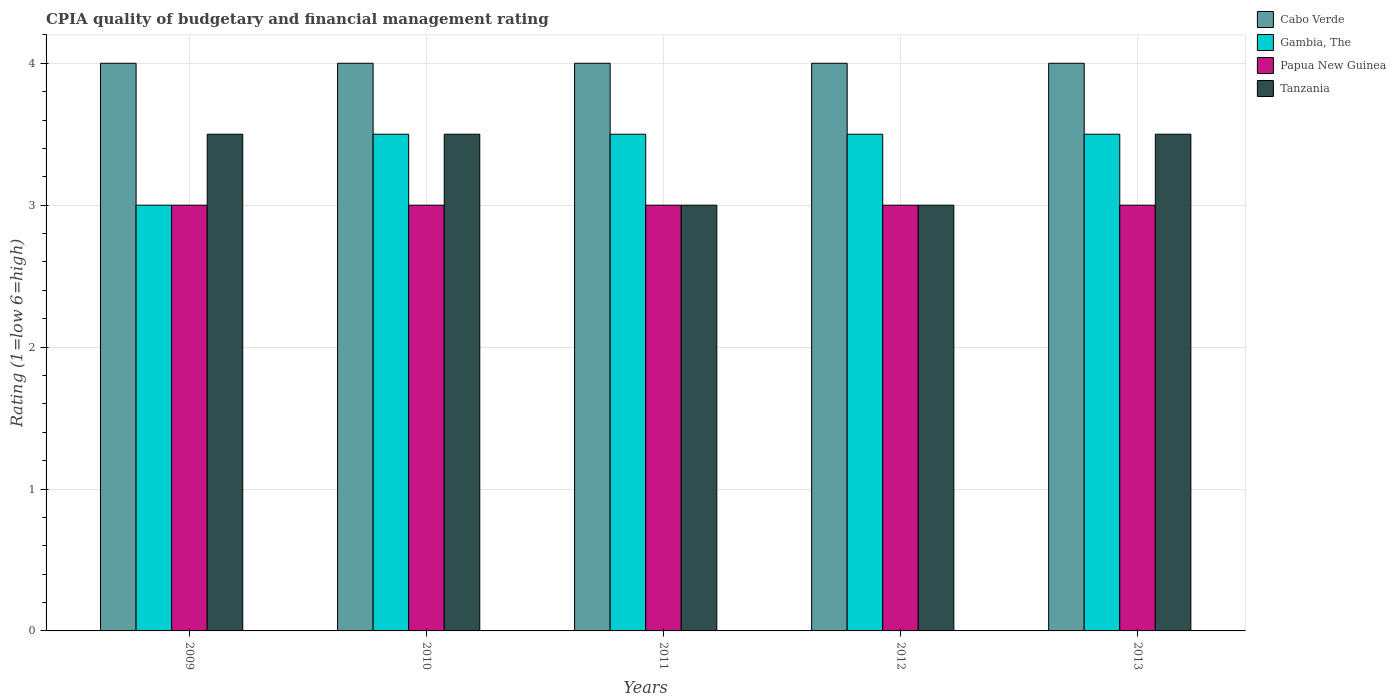How many different coloured bars are there?
Your answer should be compact. 4. Are the number of bars per tick equal to the number of legend labels?
Provide a short and direct response. Yes. Are the number of bars on each tick of the X-axis equal?
Your answer should be very brief. Yes. How many bars are there on the 5th tick from the right?
Your answer should be compact. 4. What is the label of the 2nd group of bars from the left?
Provide a succinct answer. 2010. In how many cases, is the number of bars for a given year not equal to the number of legend labels?
Your answer should be compact. 0. What is the CPIA rating in Tanzania in 2013?
Offer a very short reply. 3.5. Across all years, what is the maximum CPIA rating in Gambia, The?
Your answer should be very brief. 3.5. Across all years, what is the minimum CPIA rating in Gambia, The?
Make the answer very short. 3. What is the ratio of the CPIA rating in Papua New Guinea in 2009 to that in 2011?
Your answer should be compact. 1. Is the difference between the CPIA rating in Tanzania in 2012 and 2013 greater than the difference between the CPIA rating in Gambia, The in 2012 and 2013?
Ensure brevity in your answer.  No. What is the difference between the highest and the lowest CPIA rating in Gambia, The?
Ensure brevity in your answer.  0.5. In how many years, is the CPIA rating in Papua New Guinea greater than the average CPIA rating in Papua New Guinea taken over all years?
Provide a succinct answer. 0. Is the sum of the CPIA rating in Cabo Verde in 2009 and 2011 greater than the maximum CPIA rating in Gambia, The across all years?
Ensure brevity in your answer.  Yes. Is it the case that in every year, the sum of the CPIA rating in Tanzania and CPIA rating in Cabo Verde is greater than the sum of CPIA rating in Papua New Guinea and CPIA rating in Gambia, The?
Provide a short and direct response. No. What does the 3rd bar from the left in 2013 represents?
Ensure brevity in your answer.  Papua New Guinea. What does the 3rd bar from the right in 2012 represents?
Offer a very short reply. Gambia, The. Is it the case that in every year, the sum of the CPIA rating in Cabo Verde and CPIA rating in Papua New Guinea is greater than the CPIA rating in Tanzania?
Your response must be concise. Yes. Are all the bars in the graph horizontal?
Keep it short and to the point. No. How many years are there in the graph?
Provide a succinct answer. 5. What is the difference between two consecutive major ticks on the Y-axis?
Your answer should be very brief. 1. Are the values on the major ticks of Y-axis written in scientific E-notation?
Give a very brief answer. No. Does the graph contain any zero values?
Your response must be concise. No. Does the graph contain grids?
Your answer should be compact. Yes. How many legend labels are there?
Offer a terse response. 4. What is the title of the graph?
Provide a succinct answer. CPIA quality of budgetary and financial management rating. Does "Nicaragua" appear as one of the legend labels in the graph?
Offer a terse response. No. What is the Rating (1=low 6=high) of Papua New Guinea in 2009?
Your answer should be very brief. 3. What is the Rating (1=low 6=high) in Tanzania in 2009?
Keep it short and to the point. 3.5. What is the Rating (1=low 6=high) of Gambia, The in 2010?
Provide a short and direct response. 3.5. What is the Rating (1=low 6=high) of Papua New Guinea in 2010?
Provide a short and direct response. 3. What is the Rating (1=low 6=high) in Tanzania in 2010?
Your response must be concise. 3.5. What is the Rating (1=low 6=high) of Cabo Verde in 2011?
Offer a terse response. 4. What is the Rating (1=low 6=high) of Gambia, The in 2011?
Give a very brief answer. 3.5. What is the Rating (1=low 6=high) in Cabo Verde in 2012?
Your answer should be very brief. 4. What is the Rating (1=low 6=high) of Gambia, The in 2012?
Provide a succinct answer. 3.5. What is the Rating (1=low 6=high) in Papua New Guinea in 2012?
Offer a terse response. 3. What is the Rating (1=low 6=high) in Tanzania in 2012?
Make the answer very short. 3. What is the Rating (1=low 6=high) in Cabo Verde in 2013?
Your answer should be compact. 4. What is the Rating (1=low 6=high) in Gambia, The in 2013?
Give a very brief answer. 3.5. What is the Rating (1=low 6=high) of Papua New Guinea in 2013?
Provide a short and direct response. 3. Across all years, what is the maximum Rating (1=low 6=high) of Gambia, The?
Your answer should be compact. 3.5. Across all years, what is the minimum Rating (1=low 6=high) of Cabo Verde?
Offer a terse response. 4. Across all years, what is the minimum Rating (1=low 6=high) in Gambia, The?
Provide a short and direct response. 3. What is the total Rating (1=low 6=high) of Gambia, The in the graph?
Ensure brevity in your answer.  17. What is the total Rating (1=low 6=high) in Papua New Guinea in the graph?
Make the answer very short. 15. What is the difference between the Rating (1=low 6=high) in Cabo Verde in 2009 and that in 2010?
Offer a very short reply. 0. What is the difference between the Rating (1=low 6=high) of Gambia, The in 2009 and that in 2010?
Your answer should be very brief. -0.5. What is the difference between the Rating (1=low 6=high) in Papua New Guinea in 2009 and that in 2010?
Offer a terse response. 0. What is the difference between the Rating (1=low 6=high) of Tanzania in 2009 and that in 2010?
Give a very brief answer. 0. What is the difference between the Rating (1=low 6=high) in Cabo Verde in 2009 and that in 2011?
Your answer should be very brief. 0. What is the difference between the Rating (1=low 6=high) in Tanzania in 2009 and that in 2011?
Give a very brief answer. 0.5. What is the difference between the Rating (1=low 6=high) in Gambia, The in 2009 and that in 2012?
Your response must be concise. -0.5. What is the difference between the Rating (1=low 6=high) in Papua New Guinea in 2009 and that in 2012?
Your response must be concise. 0. What is the difference between the Rating (1=low 6=high) of Papua New Guinea in 2009 and that in 2013?
Offer a very short reply. 0. What is the difference between the Rating (1=low 6=high) of Tanzania in 2009 and that in 2013?
Ensure brevity in your answer.  0. What is the difference between the Rating (1=low 6=high) of Cabo Verde in 2010 and that in 2011?
Provide a succinct answer. 0. What is the difference between the Rating (1=low 6=high) of Cabo Verde in 2010 and that in 2012?
Offer a terse response. 0. What is the difference between the Rating (1=low 6=high) in Gambia, The in 2010 and that in 2012?
Your response must be concise. 0. What is the difference between the Rating (1=low 6=high) of Papua New Guinea in 2010 and that in 2012?
Offer a terse response. 0. What is the difference between the Rating (1=low 6=high) of Cabo Verde in 2010 and that in 2013?
Your response must be concise. 0. What is the difference between the Rating (1=low 6=high) in Papua New Guinea in 2010 and that in 2013?
Provide a succinct answer. 0. What is the difference between the Rating (1=low 6=high) of Cabo Verde in 2011 and that in 2012?
Your response must be concise. 0. What is the difference between the Rating (1=low 6=high) of Cabo Verde in 2011 and that in 2013?
Offer a very short reply. 0. What is the difference between the Rating (1=low 6=high) in Tanzania in 2011 and that in 2013?
Keep it short and to the point. -0.5. What is the difference between the Rating (1=low 6=high) in Papua New Guinea in 2012 and that in 2013?
Offer a very short reply. 0. What is the difference between the Rating (1=low 6=high) in Tanzania in 2012 and that in 2013?
Make the answer very short. -0.5. What is the difference between the Rating (1=low 6=high) of Cabo Verde in 2009 and the Rating (1=low 6=high) of Tanzania in 2010?
Make the answer very short. 0.5. What is the difference between the Rating (1=low 6=high) in Gambia, The in 2009 and the Rating (1=low 6=high) in Tanzania in 2010?
Offer a very short reply. -0.5. What is the difference between the Rating (1=low 6=high) of Cabo Verde in 2009 and the Rating (1=low 6=high) of Tanzania in 2011?
Offer a terse response. 1. What is the difference between the Rating (1=low 6=high) of Gambia, The in 2009 and the Rating (1=low 6=high) of Papua New Guinea in 2011?
Give a very brief answer. 0. What is the difference between the Rating (1=low 6=high) of Papua New Guinea in 2009 and the Rating (1=low 6=high) of Tanzania in 2011?
Keep it short and to the point. 0. What is the difference between the Rating (1=low 6=high) in Cabo Verde in 2009 and the Rating (1=low 6=high) in Gambia, The in 2012?
Make the answer very short. 0.5. What is the difference between the Rating (1=low 6=high) of Gambia, The in 2009 and the Rating (1=low 6=high) of Tanzania in 2012?
Your response must be concise. 0. What is the difference between the Rating (1=low 6=high) in Cabo Verde in 2009 and the Rating (1=low 6=high) in Gambia, The in 2013?
Keep it short and to the point. 0.5. What is the difference between the Rating (1=low 6=high) of Cabo Verde in 2009 and the Rating (1=low 6=high) of Papua New Guinea in 2013?
Your answer should be very brief. 1. What is the difference between the Rating (1=low 6=high) in Cabo Verde in 2009 and the Rating (1=low 6=high) in Tanzania in 2013?
Your answer should be compact. 0.5. What is the difference between the Rating (1=low 6=high) in Gambia, The in 2009 and the Rating (1=low 6=high) in Tanzania in 2013?
Provide a short and direct response. -0.5. What is the difference between the Rating (1=low 6=high) in Cabo Verde in 2010 and the Rating (1=low 6=high) in Tanzania in 2011?
Provide a short and direct response. 1. What is the difference between the Rating (1=low 6=high) of Gambia, The in 2010 and the Rating (1=low 6=high) of Papua New Guinea in 2011?
Offer a very short reply. 0.5. What is the difference between the Rating (1=low 6=high) in Cabo Verde in 2010 and the Rating (1=low 6=high) in Gambia, The in 2012?
Offer a terse response. 0.5. What is the difference between the Rating (1=low 6=high) of Cabo Verde in 2010 and the Rating (1=low 6=high) of Tanzania in 2012?
Keep it short and to the point. 1. What is the difference between the Rating (1=low 6=high) in Gambia, The in 2010 and the Rating (1=low 6=high) in Papua New Guinea in 2012?
Your answer should be compact. 0.5. What is the difference between the Rating (1=low 6=high) in Papua New Guinea in 2010 and the Rating (1=low 6=high) in Tanzania in 2012?
Provide a short and direct response. 0. What is the difference between the Rating (1=low 6=high) in Cabo Verde in 2010 and the Rating (1=low 6=high) in Gambia, The in 2013?
Keep it short and to the point. 0.5. What is the difference between the Rating (1=low 6=high) in Gambia, The in 2010 and the Rating (1=low 6=high) in Papua New Guinea in 2013?
Your answer should be very brief. 0.5. What is the difference between the Rating (1=low 6=high) of Papua New Guinea in 2010 and the Rating (1=low 6=high) of Tanzania in 2013?
Provide a succinct answer. -0.5. What is the difference between the Rating (1=low 6=high) in Cabo Verde in 2011 and the Rating (1=low 6=high) in Papua New Guinea in 2012?
Your response must be concise. 1. What is the difference between the Rating (1=low 6=high) of Gambia, The in 2011 and the Rating (1=low 6=high) of Papua New Guinea in 2012?
Make the answer very short. 0.5. What is the difference between the Rating (1=low 6=high) of Gambia, The in 2011 and the Rating (1=low 6=high) of Tanzania in 2012?
Offer a terse response. 0.5. What is the difference between the Rating (1=low 6=high) of Papua New Guinea in 2011 and the Rating (1=low 6=high) of Tanzania in 2012?
Provide a short and direct response. 0. What is the difference between the Rating (1=low 6=high) of Cabo Verde in 2011 and the Rating (1=low 6=high) of Tanzania in 2013?
Provide a succinct answer. 0.5. What is the difference between the Rating (1=low 6=high) of Gambia, The in 2011 and the Rating (1=low 6=high) of Papua New Guinea in 2013?
Your answer should be very brief. 0.5. What is the difference between the Rating (1=low 6=high) in Gambia, The in 2011 and the Rating (1=low 6=high) in Tanzania in 2013?
Make the answer very short. 0. What is the difference between the Rating (1=low 6=high) of Papua New Guinea in 2011 and the Rating (1=low 6=high) of Tanzania in 2013?
Ensure brevity in your answer.  -0.5. What is the difference between the Rating (1=low 6=high) of Cabo Verde in 2012 and the Rating (1=low 6=high) of Papua New Guinea in 2013?
Your response must be concise. 1. What is the difference between the Rating (1=low 6=high) of Cabo Verde in 2012 and the Rating (1=low 6=high) of Tanzania in 2013?
Your response must be concise. 0.5. What is the difference between the Rating (1=low 6=high) of Gambia, The in 2012 and the Rating (1=low 6=high) of Papua New Guinea in 2013?
Ensure brevity in your answer.  0.5. What is the difference between the Rating (1=low 6=high) of Papua New Guinea in 2012 and the Rating (1=low 6=high) of Tanzania in 2013?
Your answer should be compact. -0.5. What is the average Rating (1=low 6=high) of Gambia, The per year?
Offer a terse response. 3.4. What is the average Rating (1=low 6=high) of Papua New Guinea per year?
Keep it short and to the point. 3. In the year 2009, what is the difference between the Rating (1=low 6=high) in Cabo Verde and Rating (1=low 6=high) in Gambia, The?
Provide a succinct answer. 1. In the year 2009, what is the difference between the Rating (1=low 6=high) in Cabo Verde and Rating (1=low 6=high) in Papua New Guinea?
Keep it short and to the point. 1. In the year 2009, what is the difference between the Rating (1=low 6=high) of Gambia, The and Rating (1=low 6=high) of Tanzania?
Make the answer very short. -0.5. In the year 2010, what is the difference between the Rating (1=low 6=high) in Cabo Verde and Rating (1=low 6=high) in Gambia, The?
Provide a short and direct response. 0.5. In the year 2010, what is the difference between the Rating (1=low 6=high) in Gambia, The and Rating (1=low 6=high) in Papua New Guinea?
Offer a terse response. 0.5. In the year 2010, what is the difference between the Rating (1=low 6=high) of Gambia, The and Rating (1=low 6=high) of Tanzania?
Make the answer very short. 0. In the year 2010, what is the difference between the Rating (1=low 6=high) in Papua New Guinea and Rating (1=low 6=high) in Tanzania?
Keep it short and to the point. -0.5. In the year 2011, what is the difference between the Rating (1=low 6=high) in Cabo Verde and Rating (1=low 6=high) in Gambia, The?
Make the answer very short. 0.5. In the year 2011, what is the difference between the Rating (1=low 6=high) in Cabo Verde and Rating (1=low 6=high) in Tanzania?
Provide a succinct answer. 1. In the year 2011, what is the difference between the Rating (1=low 6=high) of Gambia, The and Rating (1=low 6=high) of Papua New Guinea?
Ensure brevity in your answer.  0.5. In the year 2011, what is the difference between the Rating (1=low 6=high) of Gambia, The and Rating (1=low 6=high) of Tanzania?
Your answer should be very brief. 0.5. In the year 2012, what is the difference between the Rating (1=low 6=high) of Cabo Verde and Rating (1=low 6=high) of Gambia, The?
Keep it short and to the point. 0.5. In the year 2012, what is the difference between the Rating (1=low 6=high) of Cabo Verde and Rating (1=low 6=high) of Papua New Guinea?
Your response must be concise. 1. In the year 2012, what is the difference between the Rating (1=low 6=high) in Cabo Verde and Rating (1=low 6=high) in Tanzania?
Keep it short and to the point. 1. In the year 2013, what is the difference between the Rating (1=low 6=high) in Cabo Verde and Rating (1=low 6=high) in Papua New Guinea?
Your answer should be compact. 1. In the year 2013, what is the difference between the Rating (1=low 6=high) in Cabo Verde and Rating (1=low 6=high) in Tanzania?
Offer a very short reply. 0.5. In the year 2013, what is the difference between the Rating (1=low 6=high) of Gambia, The and Rating (1=low 6=high) of Tanzania?
Your answer should be compact. 0. What is the ratio of the Rating (1=low 6=high) of Papua New Guinea in 2009 to that in 2010?
Your answer should be compact. 1. What is the ratio of the Rating (1=low 6=high) of Gambia, The in 2009 to that in 2012?
Provide a succinct answer. 0.86. What is the ratio of the Rating (1=low 6=high) in Papua New Guinea in 2009 to that in 2012?
Your answer should be compact. 1. What is the ratio of the Rating (1=low 6=high) of Cabo Verde in 2009 to that in 2013?
Provide a succinct answer. 1. What is the ratio of the Rating (1=low 6=high) of Cabo Verde in 2010 to that in 2011?
Your response must be concise. 1. What is the ratio of the Rating (1=low 6=high) in Gambia, The in 2010 to that in 2011?
Provide a succinct answer. 1. What is the ratio of the Rating (1=low 6=high) in Gambia, The in 2010 to that in 2012?
Your answer should be very brief. 1. What is the ratio of the Rating (1=low 6=high) in Tanzania in 2010 to that in 2012?
Ensure brevity in your answer.  1.17. What is the ratio of the Rating (1=low 6=high) in Tanzania in 2010 to that in 2013?
Your answer should be very brief. 1. What is the ratio of the Rating (1=low 6=high) of Cabo Verde in 2011 to that in 2012?
Keep it short and to the point. 1. What is the ratio of the Rating (1=low 6=high) of Papua New Guinea in 2011 to that in 2012?
Your answer should be compact. 1. What is the ratio of the Rating (1=low 6=high) of Tanzania in 2011 to that in 2012?
Provide a short and direct response. 1. What is the ratio of the Rating (1=low 6=high) of Cabo Verde in 2011 to that in 2013?
Give a very brief answer. 1. What is the ratio of the Rating (1=low 6=high) in Gambia, The in 2011 to that in 2013?
Your answer should be compact. 1. What is the ratio of the Rating (1=low 6=high) of Papua New Guinea in 2011 to that in 2013?
Your response must be concise. 1. What is the ratio of the Rating (1=low 6=high) of Tanzania in 2011 to that in 2013?
Your answer should be very brief. 0.86. What is the ratio of the Rating (1=low 6=high) of Gambia, The in 2012 to that in 2013?
Provide a short and direct response. 1. What is the ratio of the Rating (1=low 6=high) in Papua New Guinea in 2012 to that in 2013?
Your answer should be compact. 1. What is the difference between the highest and the second highest Rating (1=low 6=high) in Cabo Verde?
Offer a very short reply. 0. What is the difference between the highest and the second highest Rating (1=low 6=high) of Papua New Guinea?
Your answer should be very brief. 0. What is the difference between the highest and the lowest Rating (1=low 6=high) of Cabo Verde?
Your answer should be very brief. 0. What is the difference between the highest and the lowest Rating (1=low 6=high) in Papua New Guinea?
Provide a succinct answer. 0. 